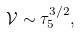Convert formula to latex. <formula><loc_0><loc_0><loc_500><loc_500>\mathcal { V } \sim \tau _ { 5 } ^ { 3 / 2 } ,</formula> 